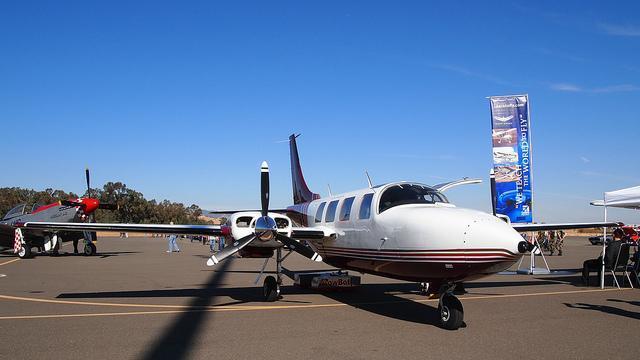How many pilots are in the cockpit?
Give a very brief answer. 0. How many airplanes are there?
Give a very brief answer. 2. 